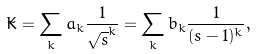<formula> <loc_0><loc_0><loc_500><loc_500>\tilde { K } = \sum _ { k } a _ { k } \frac { 1 } { \sqrt { s } ^ { k } } = \sum _ { k } b _ { k } \frac { 1 } { ( s - 1 ) ^ { k } } ,</formula> 